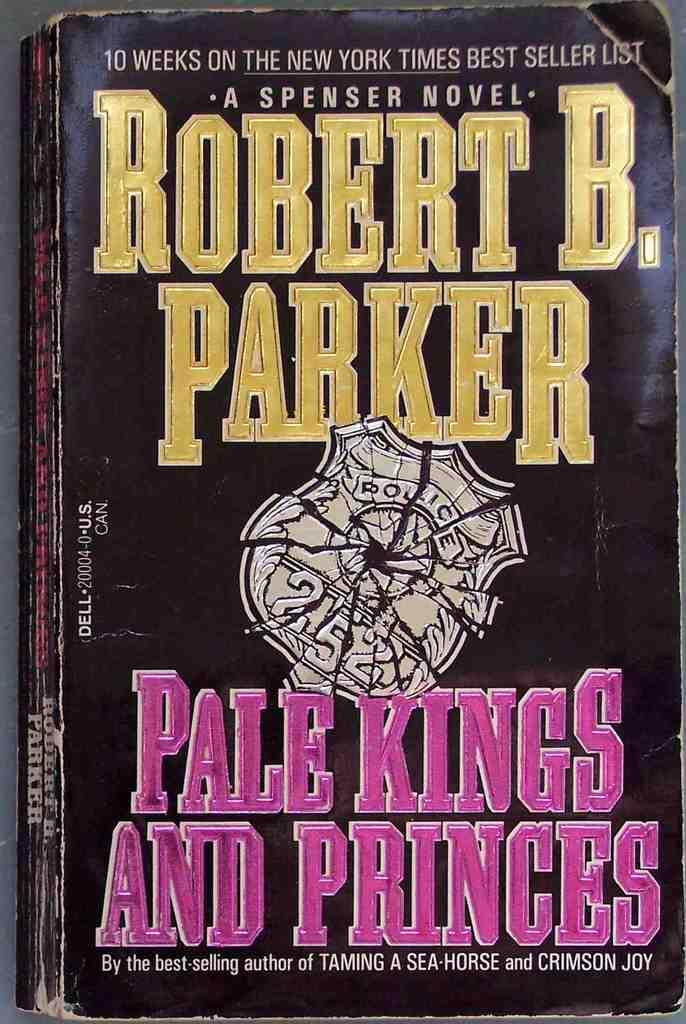<image>
Create a compact narrative representing the image presented. the novel "pale kings and the princes" by Robert B. Parker 